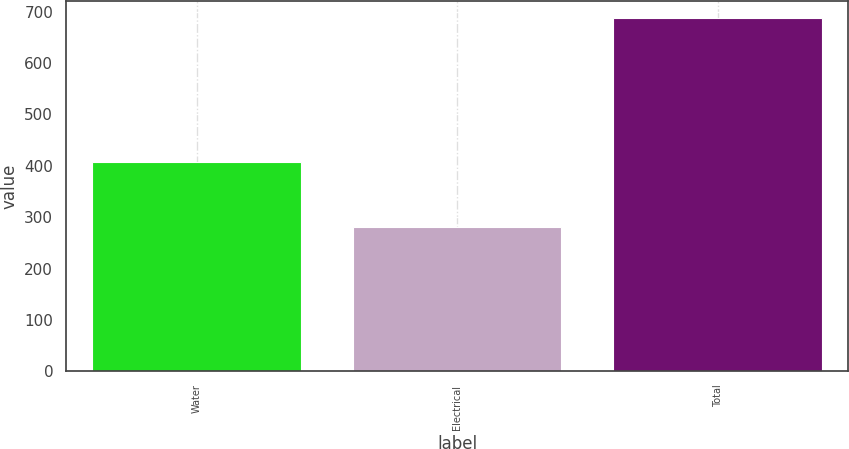Convert chart to OTSL. <chart><loc_0><loc_0><loc_500><loc_500><bar_chart><fcel>Water<fcel>Electrical<fcel>Total<nl><fcel>406.9<fcel>280.4<fcel>687.3<nl></chart> 